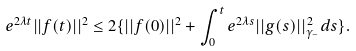Convert formula to latex. <formula><loc_0><loc_0><loc_500><loc_500>e ^ { 2 \lambda t } | | f ( t ) | | ^ { 2 } \leq 2 \{ | | f ( 0 ) | | ^ { 2 } + \int _ { 0 } ^ { t } e ^ { 2 \lambda s } | | g ( s ) | | _ { \gamma _ { - } } ^ { 2 } d s \} .</formula> 